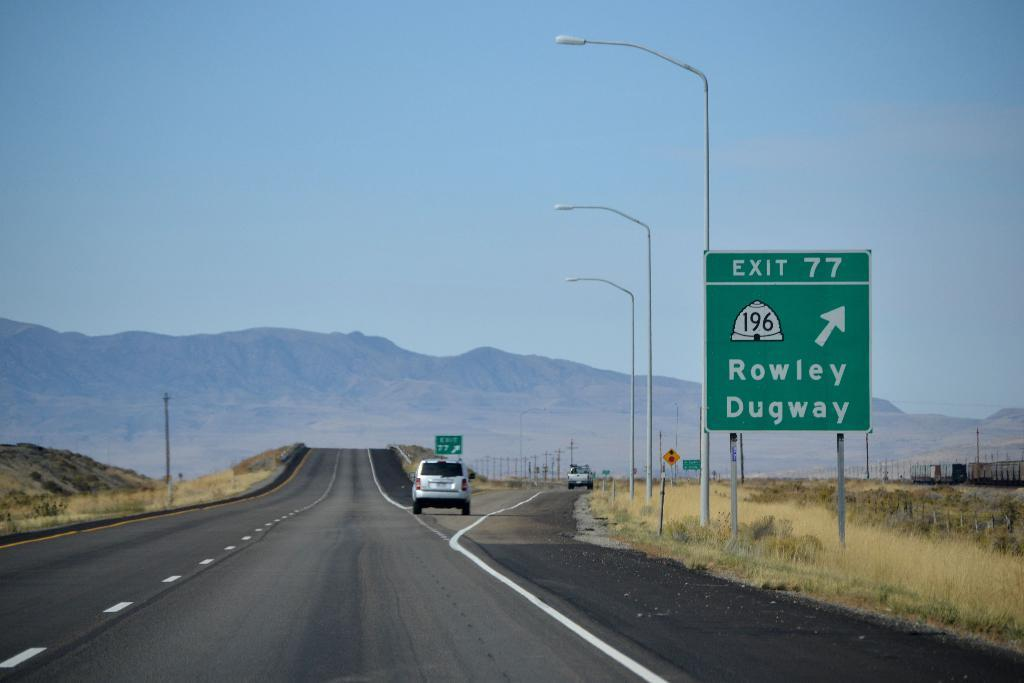<image>
Share a concise interpretation of the image provided. A road with mountain in the backyard and a sign for exit 77 Rowley and Dugway. 